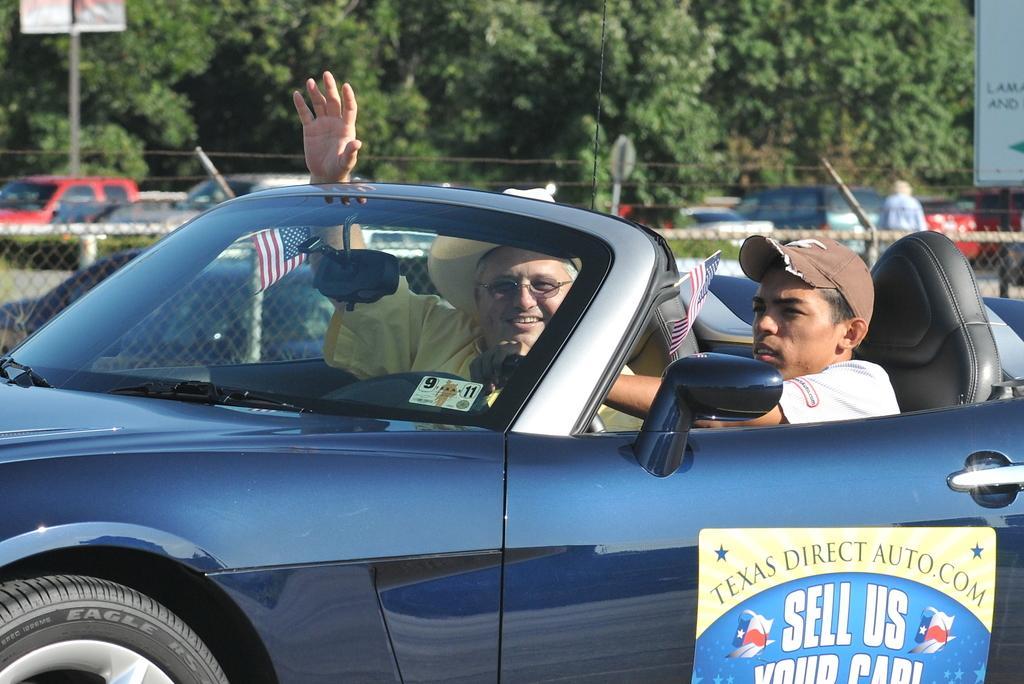In one or two sentences, can you explain what this image depicts? This image consists of two persons sitting in a car, the person at the right side is sitting at the steering seat and the person in the center is showing his hand and is having smile on his face. On the door of the car there is some words written texas direct auto. com sell us your car. In the background there are some trees and some cars are visible. There is a signboard at the right side and on the left side there is a sign board. 